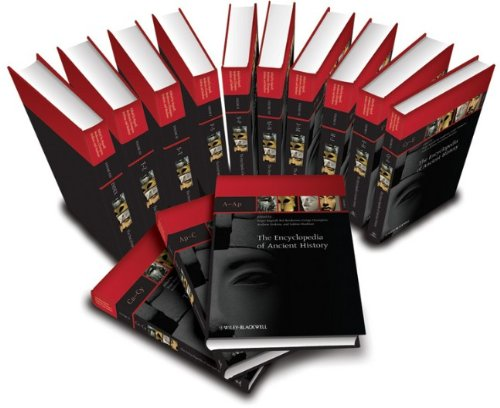What is the title of this book? The book in the image is titled 'The Encyclopedia of Ancient History, 13 Volume Set'. This extensive collection delves deep into the historical events, figures, and cultures of ancient times. 